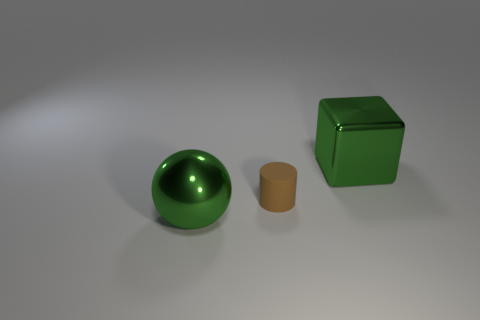Is there anything else that has the same material as the small object?
Give a very brief answer. No. Are the large object in front of the small brown cylinder and the tiny cylinder on the left side of the big cube made of the same material?
Your response must be concise. No. There is a tiny brown rubber object; does it have the same shape as the green shiny thing in front of the cube?
Provide a short and direct response. No. What number of small things are either blue matte cubes or matte things?
Your response must be concise. 1. What size is the metallic thing that is the same color as the big metal cube?
Your answer should be very brief. Large. There is a big thing on the right side of the green object in front of the small rubber cylinder; what is its color?
Provide a succinct answer. Green. Is the material of the brown thing the same as the green object to the right of the ball?
Offer a very short reply. No. What is the material of the green object that is in front of the small brown matte object?
Make the answer very short. Metal. Is the number of brown rubber things in front of the metal cube the same as the number of big purple metal blocks?
Your answer should be compact. No. Is there anything else that has the same size as the brown matte object?
Provide a succinct answer. No. 